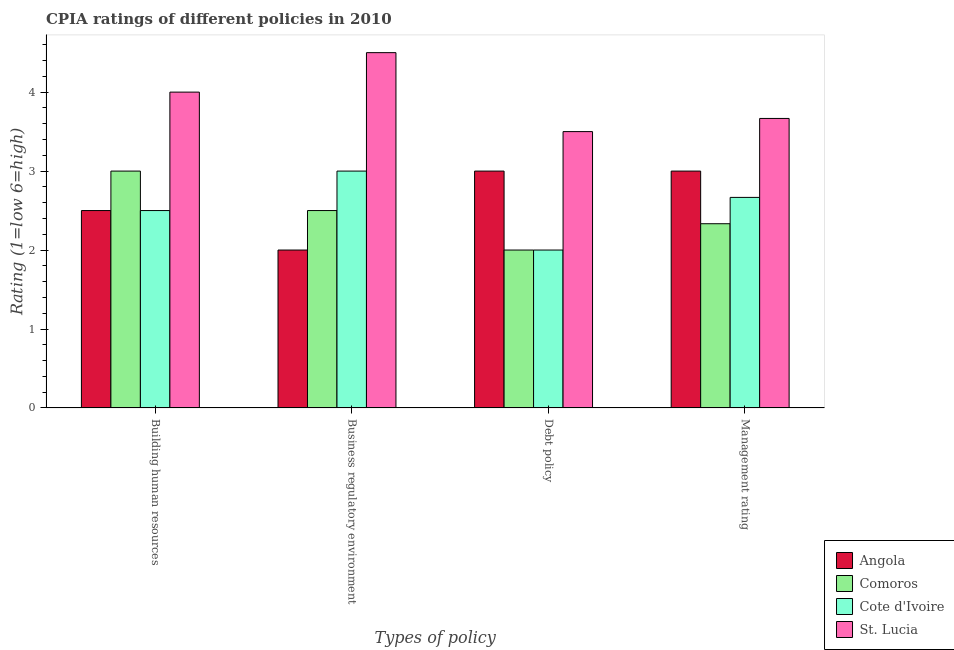How many different coloured bars are there?
Your response must be concise. 4. How many groups of bars are there?
Provide a short and direct response. 4. What is the label of the 4th group of bars from the left?
Keep it short and to the point. Management rating. Across all countries, what is the maximum cpia rating of business regulatory environment?
Keep it short and to the point. 4.5. Across all countries, what is the minimum cpia rating of management?
Offer a very short reply. 2.33. In which country was the cpia rating of building human resources maximum?
Offer a terse response. St. Lucia. In which country was the cpia rating of management minimum?
Give a very brief answer. Comoros. What is the difference between the cpia rating of building human resources in Comoros and the cpia rating of management in Cote d'Ivoire?
Keep it short and to the point. 0.33. What is the difference between the cpia rating of management and cpia rating of debt policy in Angola?
Keep it short and to the point. 0. In how many countries, is the cpia rating of debt policy greater than 3.8 ?
Your answer should be very brief. 0. What is the ratio of the cpia rating of debt policy in Angola to that in St. Lucia?
Offer a very short reply. 0.86. Is the cpia rating of building human resources in Cote d'Ivoire less than that in Comoros?
Your answer should be compact. Yes. Is the difference between the cpia rating of management in Angola and St. Lucia greater than the difference between the cpia rating of business regulatory environment in Angola and St. Lucia?
Your response must be concise. Yes. What is the difference between the highest and the lowest cpia rating of management?
Give a very brief answer. 1.33. Is it the case that in every country, the sum of the cpia rating of debt policy and cpia rating of building human resources is greater than the sum of cpia rating of business regulatory environment and cpia rating of management?
Provide a short and direct response. No. What does the 2nd bar from the left in Debt policy represents?
Ensure brevity in your answer.  Comoros. What does the 1st bar from the right in Management rating represents?
Offer a terse response. St. Lucia. Is it the case that in every country, the sum of the cpia rating of building human resources and cpia rating of business regulatory environment is greater than the cpia rating of debt policy?
Provide a succinct answer. Yes. How many bars are there?
Provide a succinct answer. 16. Are all the bars in the graph horizontal?
Give a very brief answer. No. What is the difference between two consecutive major ticks on the Y-axis?
Keep it short and to the point. 1. Does the graph contain grids?
Your response must be concise. No. Where does the legend appear in the graph?
Give a very brief answer. Bottom right. How many legend labels are there?
Provide a short and direct response. 4. How are the legend labels stacked?
Ensure brevity in your answer.  Vertical. What is the title of the graph?
Keep it short and to the point. CPIA ratings of different policies in 2010. Does "Paraguay" appear as one of the legend labels in the graph?
Keep it short and to the point. No. What is the label or title of the X-axis?
Offer a very short reply. Types of policy. What is the label or title of the Y-axis?
Make the answer very short. Rating (1=low 6=high). What is the Rating (1=low 6=high) of Angola in Building human resources?
Ensure brevity in your answer.  2.5. What is the Rating (1=low 6=high) in St. Lucia in Building human resources?
Your response must be concise. 4. What is the Rating (1=low 6=high) in Angola in Business regulatory environment?
Your answer should be compact. 2. What is the Rating (1=low 6=high) in Comoros in Business regulatory environment?
Your response must be concise. 2.5. What is the Rating (1=low 6=high) in Cote d'Ivoire in Business regulatory environment?
Make the answer very short. 3. What is the Rating (1=low 6=high) of St. Lucia in Business regulatory environment?
Offer a terse response. 4.5. What is the Rating (1=low 6=high) in Angola in Debt policy?
Give a very brief answer. 3. What is the Rating (1=low 6=high) in Comoros in Debt policy?
Keep it short and to the point. 2. What is the Rating (1=low 6=high) in St. Lucia in Debt policy?
Provide a succinct answer. 3.5. What is the Rating (1=low 6=high) of Comoros in Management rating?
Offer a very short reply. 2.33. What is the Rating (1=low 6=high) in Cote d'Ivoire in Management rating?
Ensure brevity in your answer.  2.67. What is the Rating (1=low 6=high) in St. Lucia in Management rating?
Your answer should be compact. 3.67. Across all Types of policy, what is the maximum Rating (1=low 6=high) in Comoros?
Provide a succinct answer. 3. Across all Types of policy, what is the minimum Rating (1=low 6=high) in Comoros?
Offer a very short reply. 2. Across all Types of policy, what is the minimum Rating (1=low 6=high) of Cote d'Ivoire?
Ensure brevity in your answer.  2. What is the total Rating (1=low 6=high) in Angola in the graph?
Provide a short and direct response. 10.5. What is the total Rating (1=low 6=high) in Comoros in the graph?
Offer a terse response. 9.83. What is the total Rating (1=low 6=high) of Cote d'Ivoire in the graph?
Keep it short and to the point. 10.17. What is the total Rating (1=low 6=high) of St. Lucia in the graph?
Keep it short and to the point. 15.67. What is the difference between the Rating (1=low 6=high) in Comoros in Building human resources and that in Business regulatory environment?
Keep it short and to the point. 0.5. What is the difference between the Rating (1=low 6=high) of St. Lucia in Building human resources and that in Business regulatory environment?
Make the answer very short. -0.5. What is the difference between the Rating (1=low 6=high) of St. Lucia in Building human resources and that in Debt policy?
Your answer should be very brief. 0.5. What is the difference between the Rating (1=low 6=high) of Comoros in Building human resources and that in Management rating?
Your answer should be compact. 0.67. What is the difference between the Rating (1=low 6=high) in Angola in Business regulatory environment and that in Debt policy?
Ensure brevity in your answer.  -1. What is the difference between the Rating (1=low 6=high) in Comoros in Business regulatory environment and that in Debt policy?
Make the answer very short. 0.5. What is the difference between the Rating (1=low 6=high) in Angola in Business regulatory environment and that in Management rating?
Provide a succinct answer. -1. What is the difference between the Rating (1=low 6=high) of Comoros in Business regulatory environment and that in Management rating?
Give a very brief answer. 0.17. What is the difference between the Rating (1=low 6=high) in Cote d'Ivoire in Business regulatory environment and that in Management rating?
Your response must be concise. 0.33. What is the difference between the Rating (1=low 6=high) of Comoros in Debt policy and that in Management rating?
Offer a terse response. -0.33. What is the difference between the Rating (1=low 6=high) of Cote d'Ivoire in Debt policy and that in Management rating?
Provide a short and direct response. -0.67. What is the difference between the Rating (1=low 6=high) of Angola in Building human resources and the Rating (1=low 6=high) of Comoros in Business regulatory environment?
Offer a terse response. 0. What is the difference between the Rating (1=low 6=high) in Comoros in Building human resources and the Rating (1=low 6=high) in Cote d'Ivoire in Business regulatory environment?
Make the answer very short. 0. What is the difference between the Rating (1=low 6=high) in Angola in Building human resources and the Rating (1=low 6=high) in Comoros in Debt policy?
Ensure brevity in your answer.  0.5. What is the difference between the Rating (1=low 6=high) in Comoros in Building human resources and the Rating (1=low 6=high) in Cote d'Ivoire in Debt policy?
Make the answer very short. 1. What is the difference between the Rating (1=low 6=high) in Angola in Building human resources and the Rating (1=low 6=high) in Cote d'Ivoire in Management rating?
Your response must be concise. -0.17. What is the difference between the Rating (1=low 6=high) in Angola in Building human resources and the Rating (1=low 6=high) in St. Lucia in Management rating?
Offer a terse response. -1.17. What is the difference between the Rating (1=low 6=high) of Comoros in Building human resources and the Rating (1=low 6=high) of Cote d'Ivoire in Management rating?
Provide a succinct answer. 0.33. What is the difference between the Rating (1=low 6=high) of Cote d'Ivoire in Building human resources and the Rating (1=low 6=high) of St. Lucia in Management rating?
Your answer should be very brief. -1.17. What is the difference between the Rating (1=low 6=high) of Angola in Business regulatory environment and the Rating (1=low 6=high) of St. Lucia in Debt policy?
Your answer should be very brief. -1.5. What is the difference between the Rating (1=low 6=high) in Cote d'Ivoire in Business regulatory environment and the Rating (1=low 6=high) in St. Lucia in Debt policy?
Offer a terse response. -0.5. What is the difference between the Rating (1=low 6=high) in Angola in Business regulatory environment and the Rating (1=low 6=high) in Comoros in Management rating?
Provide a succinct answer. -0.33. What is the difference between the Rating (1=low 6=high) in Angola in Business regulatory environment and the Rating (1=low 6=high) in St. Lucia in Management rating?
Keep it short and to the point. -1.67. What is the difference between the Rating (1=low 6=high) in Comoros in Business regulatory environment and the Rating (1=low 6=high) in St. Lucia in Management rating?
Provide a succinct answer. -1.17. What is the difference between the Rating (1=low 6=high) in Angola in Debt policy and the Rating (1=low 6=high) in Comoros in Management rating?
Offer a very short reply. 0.67. What is the difference between the Rating (1=low 6=high) in Comoros in Debt policy and the Rating (1=low 6=high) in Cote d'Ivoire in Management rating?
Give a very brief answer. -0.67. What is the difference between the Rating (1=low 6=high) of Comoros in Debt policy and the Rating (1=low 6=high) of St. Lucia in Management rating?
Your response must be concise. -1.67. What is the difference between the Rating (1=low 6=high) of Cote d'Ivoire in Debt policy and the Rating (1=low 6=high) of St. Lucia in Management rating?
Keep it short and to the point. -1.67. What is the average Rating (1=low 6=high) in Angola per Types of policy?
Your answer should be very brief. 2.62. What is the average Rating (1=low 6=high) of Comoros per Types of policy?
Provide a short and direct response. 2.46. What is the average Rating (1=low 6=high) of Cote d'Ivoire per Types of policy?
Your answer should be compact. 2.54. What is the average Rating (1=low 6=high) in St. Lucia per Types of policy?
Provide a succinct answer. 3.92. What is the difference between the Rating (1=low 6=high) in Angola and Rating (1=low 6=high) in Comoros in Building human resources?
Provide a short and direct response. -0.5. What is the difference between the Rating (1=low 6=high) of Comoros and Rating (1=low 6=high) of St. Lucia in Building human resources?
Make the answer very short. -1. What is the difference between the Rating (1=low 6=high) in Cote d'Ivoire and Rating (1=low 6=high) in St. Lucia in Building human resources?
Provide a succinct answer. -1.5. What is the difference between the Rating (1=low 6=high) in Angola and Rating (1=low 6=high) in Comoros in Business regulatory environment?
Make the answer very short. -0.5. What is the difference between the Rating (1=low 6=high) of Angola and Rating (1=low 6=high) of St. Lucia in Business regulatory environment?
Provide a short and direct response. -2.5. What is the difference between the Rating (1=low 6=high) of Comoros and Rating (1=low 6=high) of Cote d'Ivoire in Business regulatory environment?
Your response must be concise. -0.5. What is the difference between the Rating (1=low 6=high) in Comoros and Rating (1=low 6=high) in St. Lucia in Business regulatory environment?
Make the answer very short. -2. What is the difference between the Rating (1=low 6=high) of Angola and Rating (1=low 6=high) of Comoros in Debt policy?
Ensure brevity in your answer.  1. What is the difference between the Rating (1=low 6=high) of Comoros and Rating (1=low 6=high) of Cote d'Ivoire in Debt policy?
Provide a succinct answer. 0. What is the difference between the Rating (1=low 6=high) in Cote d'Ivoire and Rating (1=low 6=high) in St. Lucia in Debt policy?
Your answer should be very brief. -1.5. What is the difference between the Rating (1=low 6=high) in Angola and Rating (1=low 6=high) in Comoros in Management rating?
Ensure brevity in your answer.  0.67. What is the difference between the Rating (1=low 6=high) of Angola and Rating (1=low 6=high) of Cote d'Ivoire in Management rating?
Provide a short and direct response. 0.33. What is the difference between the Rating (1=low 6=high) of Angola and Rating (1=low 6=high) of St. Lucia in Management rating?
Ensure brevity in your answer.  -0.67. What is the difference between the Rating (1=low 6=high) of Comoros and Rating (1=low 6=high) of Cote d'Ivoire in Management rating?
Offer a very short reply. -0.33. What is the difference between the Rating (1=low 6=high) of Comoros and Rating (1=low 6=high) of St. Lucia in Management rating?
Ensure brevity in your answer.  -1.33. What is the ratio of the Rating (1=low 6=high) in Comoros in Building human resources to that in Business regulatory environment?
Your answer should be compact. 1.2. What is the ratio of the Rating (1=low 6=high) of Cote d'Ivoire in Building human resources to that in Business regulatory environment?
Give a very brief answer. 0.83. What is the ratio of the Rating (1=low 6=high) in St. Lucia in Building human resources to that in Business regulatory environment?
Offer a very short reply. 0.89. What is the ratio of the Rating (1=low 6=high) of Angola in Building human resources to that in Debt policy?
Offer a terse response. 0.83. What is the ratio of the Rating (1=low 6=high) in Comoros in Building human resources to that in Management rating?
Give a very brief answer. 1.29. What is the ratio of the Rating (1=low 6=high) of Angola in Business regulatory environment to that in Debt policy?
Make the answer very short. 0.67. What is the ratio of the Rating (1=low 6=high) of Cote d'Ivoire in Business regulatory environment to that in Debt policy?
Offer a very short reply. 1.5. What is the ratio of the Rating (1=low 6=high) in Comoros in Business regulatory environment to that in Management rating?
Provide a succinct answer. 1.07. What is the ratio of the Rating (1=low 6=high) in St. Lucia in Business regulatory environment to that in Management rating?
Ensure brevity in your answer.  1.23. What is the ratio of the Rating (1=low 6=high) of Comoros in Debt policy to that in Management rating?
Offer a very short reply. 0.86. What is the ratio of the Rating (1=low 6=high) of St. Lucia in Debt policy to that in Management rating?
Your answer should be very brief. 0.95. What is the difference between the highest and the second highest Rating (1=low 6=high) in Comoros?
Keep it short and to the point. 0.5. What is the difference between the highest and the second highest Rating (1=low 6=high) in St. Lucia?
Your answer should be compact. 0.5. 